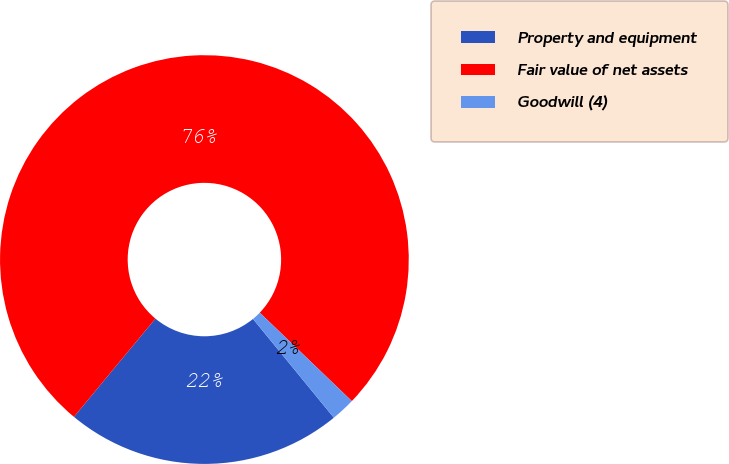Convert chart. <chart><loc_0><loc_0><loc_500><loc_500><pie_chart><fcel>Property and equipment<fcel>Fair value of net assets<fcel>Goodwill (4)<nl><fcel>21.94%<fcel>76.16%<fcel>1.91%<nl></chart> 